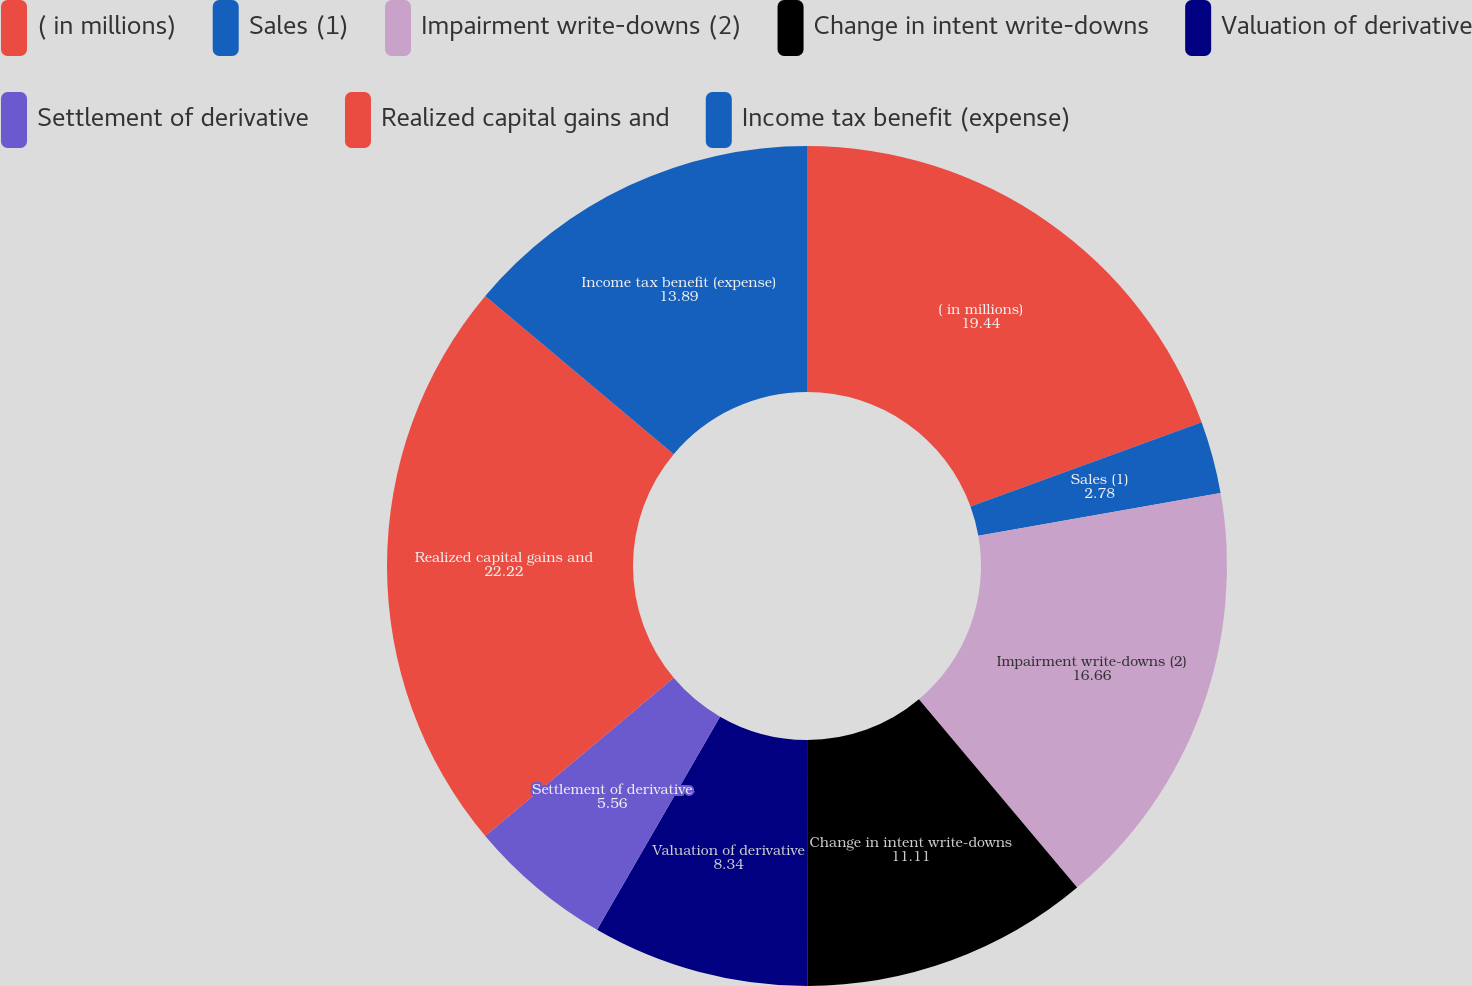Convert chart. <chart><loc_0><loc_0><loc_500><loc_500><pie_chart><fcel>( in millions)<fcel>Sales (1)<fcel>Impairment write-downs (2)<fcel>Change in intent write-downs<fcel>Valuation of derivative<fcel>Settlement of derivative<fcel>Realized capital gains and<fcel>Income tax benefit (expense)<nl><fcel>19.44%<fcel>2.78%<fcel>16.66%<fcel>11.11%<fcel>8.34%<fcel>5.56%<fcel>22.22%<fcel>13.89%<nl></chart> 